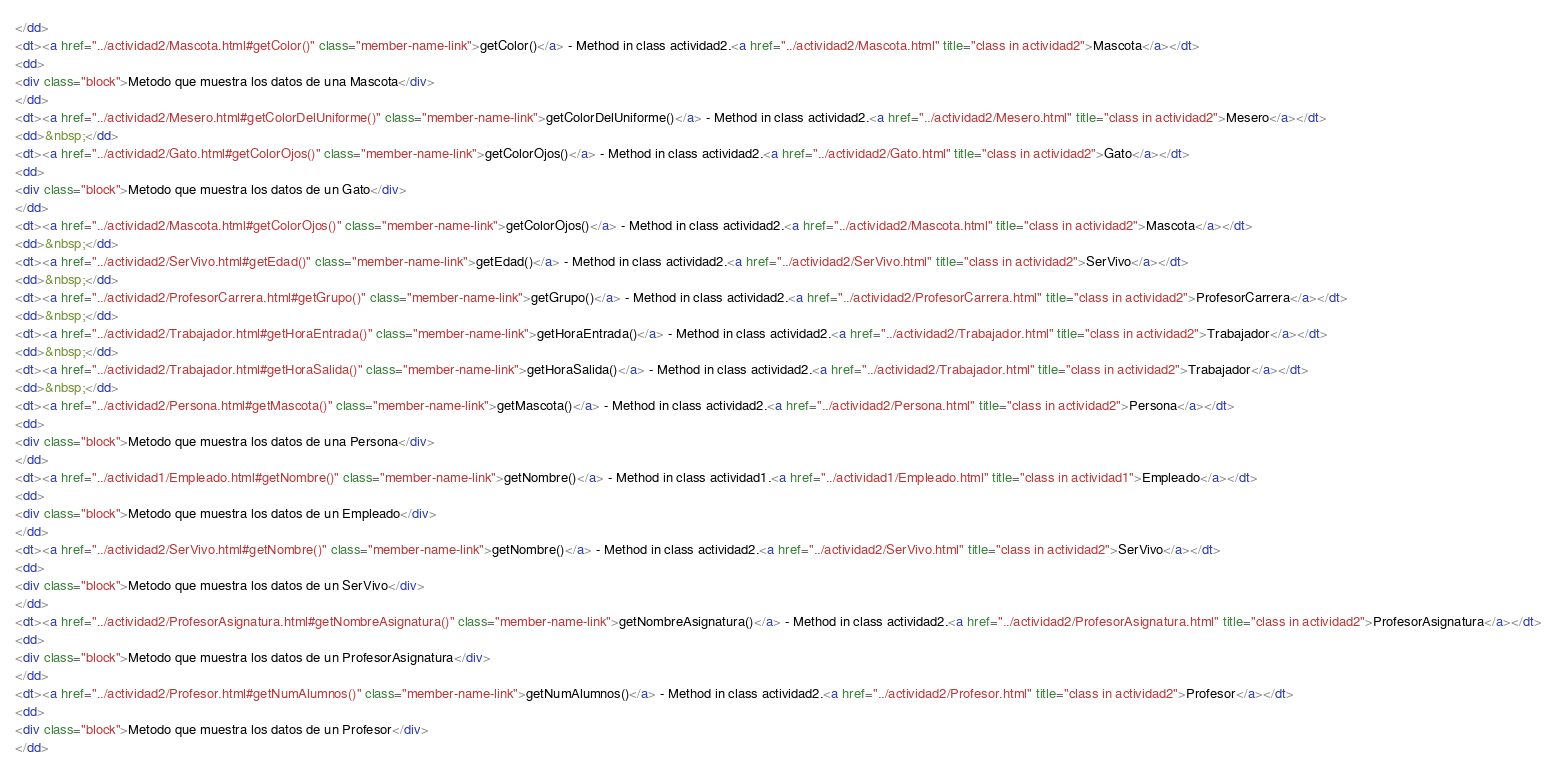Convert code to text. <code><loc_0><loc_0><loc_500><loc_500><_HTML_></dd>
<dt><a href="../actividad2/Mascota.html#getColor()" class="member-name-link">getColor()</a> - Method in class actividad2.<a href="../actividad2/Mascota.html" title="class in actividad2">Mascota</a></dt>
<dd>
<div class="block">Metodo que muestra los datos de una Mascota</div>
</dd>
<dt><a href="../actividad2/Mesero.html#getColorDelUniforme()" class="member-name-link">getColorDelUniforme()</a> - Method in class actividad2.<a href="../actividad2/Mesero.html" title="class in actividad2">Mesero</a></dt>
<dd>&nbsp;</dd>
<dt><a href="../actividad2/Gato.html#getColorOjos()" class="member-name-link">getColorOjos()</a> - Method in class actividad2.<a href="../actividad2/Gato.html" title="class in actividad2">Gato</a></dt>
<dd>
<div class="block">Metodo que muestra los datos de un Gato</div>
</dd>
<dt><a href="../actividad2/Mascota.html#getColorOjos()" class="member-name-link">getColorOjos()</a> - Method in class actividad2.<a href="../actividad2/Mascota.html" title="class in actividad2">Mascota</a></dt>
<dd>&nbsp;</dd>
<dt><a href="../actividad2/SerVivo.html#getEdad()" class="member-name-link">getEdad()</a> - Method in class actividad2.<a href="../actividad2/SerVivo.html" title="class in actividad2">SerVivo</a></dt>
<dd>&nbsp;</dd>
<dt><a href="../actividad2/ProfesorCarrera.html#getGrupo()" class="member-name-link">getGrupo()</a> - Method in class actividad2.<a href="../actividad2/ProfesorCarrera.html" title="class in actividad2">ProfesorCarrera</a></dt>
<dd>&nbsp;</dd>
<dt><a href="../actividad2/Trabajador.html#getHoraEntrada()" class="member-name-link">getHoraEntrada()</a> - Method in class actividad2.<a href="../actividad2/Trabajador.html" title="class in actividad2">Trabajador</a></dt>
<dd>&nbsp;</dd>
<dt><a href="../actividad2/Trabajador.html#getHoraSalida()" class="member-name-link">getHoraSalida()</a> - Method in class actividad2.<a href="../actividad2/Trabajador.html" title="class in actividad2">Trabajador</a></dt>
<dd>&nbsp;</dd>
<dt><a href="../actividad2/Persona.html#getMascota()" class="member-name-link">getMascota()</a> - Method in class actividad2.<a href="../actividad2/Persona.html" title="class in actividad2">Persona</a></dt>
<dd>
<div class="block">Metodo que muestra los datos de una Persona</div>
</dd>
<dt><a href="../actividad1/Empleado.html#getNombre()" class="member-name-link">getNombre()</a> - Method in class actividad1.<a href="../actividad1/Empleado.html" title="class in actividad1">Empleado</a></dt>
<dd>
<div class="block">Metodo que muestra los datos de un Empleado</div>
</dd>
<dt><a href="../actividad2/SerVivo.html#getNombre()" class="member-name-link">getNombre()</a> - Method in class actividad2.<a href="../actividad2/SerVivo.html" title="class in actividad2">SerVivo</a></dt>
<dd>
<div class="block">Metodo que muestra los datos de un SerVivo</div>
</dd>
<dt><a href="../actividad2/ProfesorAsignatura.html#getNombreAsignatura()" class="member-name-link">getNombreAsignatura()</a> - Method in class actividad2.<a href="../actividad2/ProfesorAsignatura.html" title="class in actividad2">ProfesorAsignatura</a></dt>
<dd>
<div class="block">Metodo que muestra los datos de un ProfesorAsignatura</div>
</dd>
<dt><a href="../actividad2/Profesor.html#getNumAlumnos()" class="member-name-link">getNumAlumnos()</a> - Method in class actividad2.<a href="../actividad2/Profesor.html" title="class in actividad2">Profesor</a></dt>
<dd>
<div class="block">Metodo que muestra los datos de un Profesor</div>
</dd></code> 